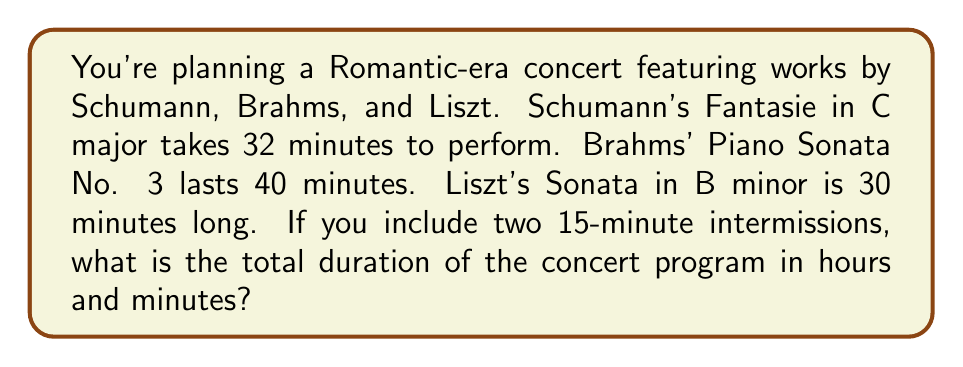Show me your answer to this math problem. Let's solve this problem step by step:

1. First, let's add up the duration of all musical pieces:
   $$32 + 40 + 30 = 102$$ minutes

2. Now, add the time for the two intermissions:
   $$102 + (15 \times 2) = 102 + 30 = 132$$ minutes

3. To convert 132 minutes to hours and minutes, we divide by 60:
   $$132 \div 60 = 2$$ remainder $$12$$

4. This means we have 2 full hours and 12 minutes.

Therefore, the total duration of the concert program is 2 hours and 12 minutes.
Answer: 2 hours 12 minutes 